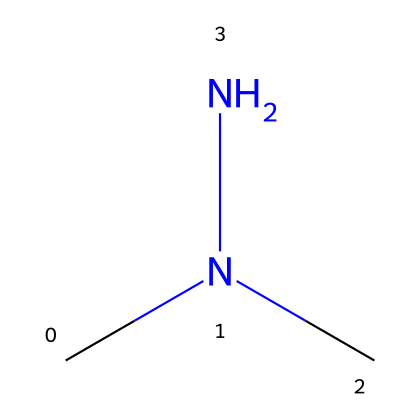What is the molecular formula of 1,1-dimethylhydrazine? The SMILES representation indicates there are two methyl groups (CN) attached to a hydrazine (N-N) core. Counting the atoms gives us a total of four carbon atoms, ten hydrogen atoms, and two nitrogen atoms, which leads to the molecular formula C2H8N2.
Answer: C2H8N2 How many nitrogen atoms are present in 1,1-dimethylhydrazine? From the SMILES format, we can discern that there are two nitrogen atoms (N) within the structure, directly indicating the count.
Answer: 2 What type of chemical is 1,1-dimethylhydrazine? The presence of the hydrazine functional group (N-N) indicates that this compound is classified as a hydrazine.
Answer: hydrazine What is the total number of hydrogen atoms in 1,1-dimethylhydrazine? Analyzing the structure reveals that there are eight hydrogen atoms connected to the methyl and hydrazine groups. Counting them leads to a total of 8 hydrogen atoms.
Answer: 8 Does 1,1-dimethylhydrazine have any functional groups? The structure includes an amine (N-H) and a hydrazine group (N-N), which qualifies it as having functional groups.
Answer: yes What are the primary uses of 1,1-dimethylhydrazine in industry? 1,1-dimethylhydrazine is commonly used as a rocket fuel and a solvent in various applications due to its energetic properties.
Answer: rocket fuel and solvent 